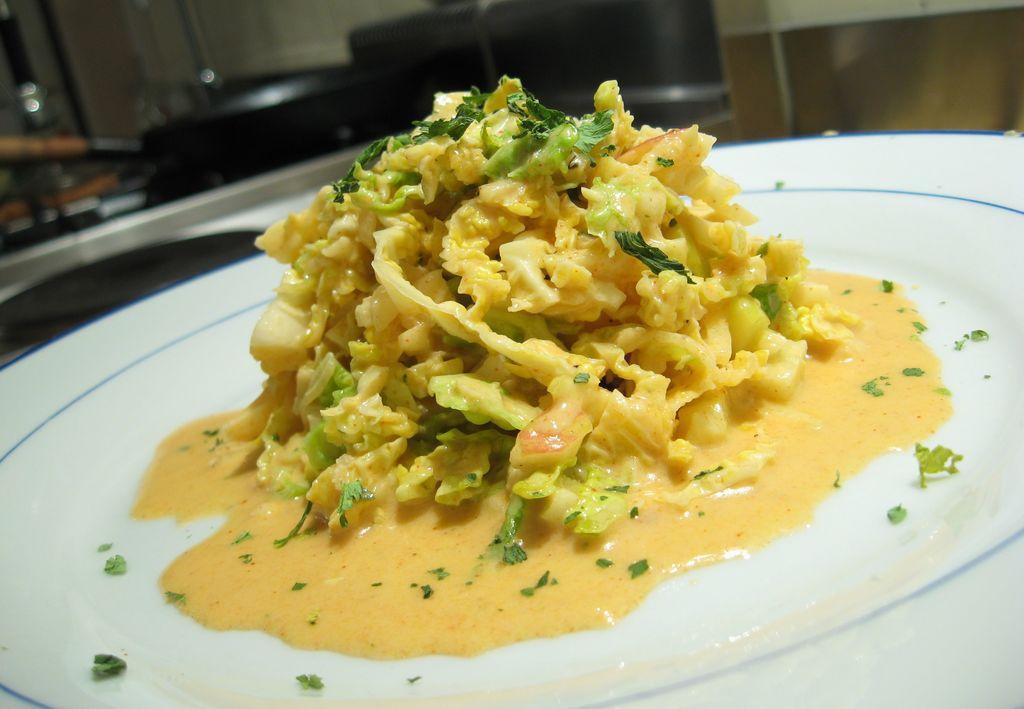Can you describe this image briefly? In this image in the foreground there is one plate and in the plate there is some food, and in the background there are some objects. 